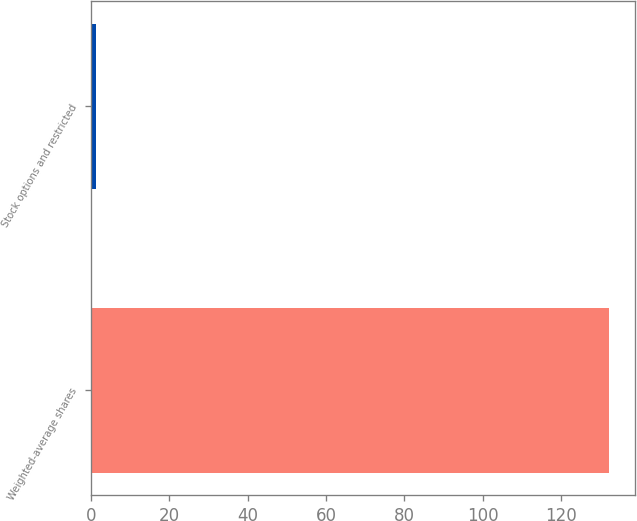Convert chart to OTSL. <chart><loc_0><loc_0><loc_500><loc_500><bar_chart><fcel>Weighted-average shares<fcel>Stock options and restricted<nl><fcel>132.11<fcel>1.4<nl></chart> 